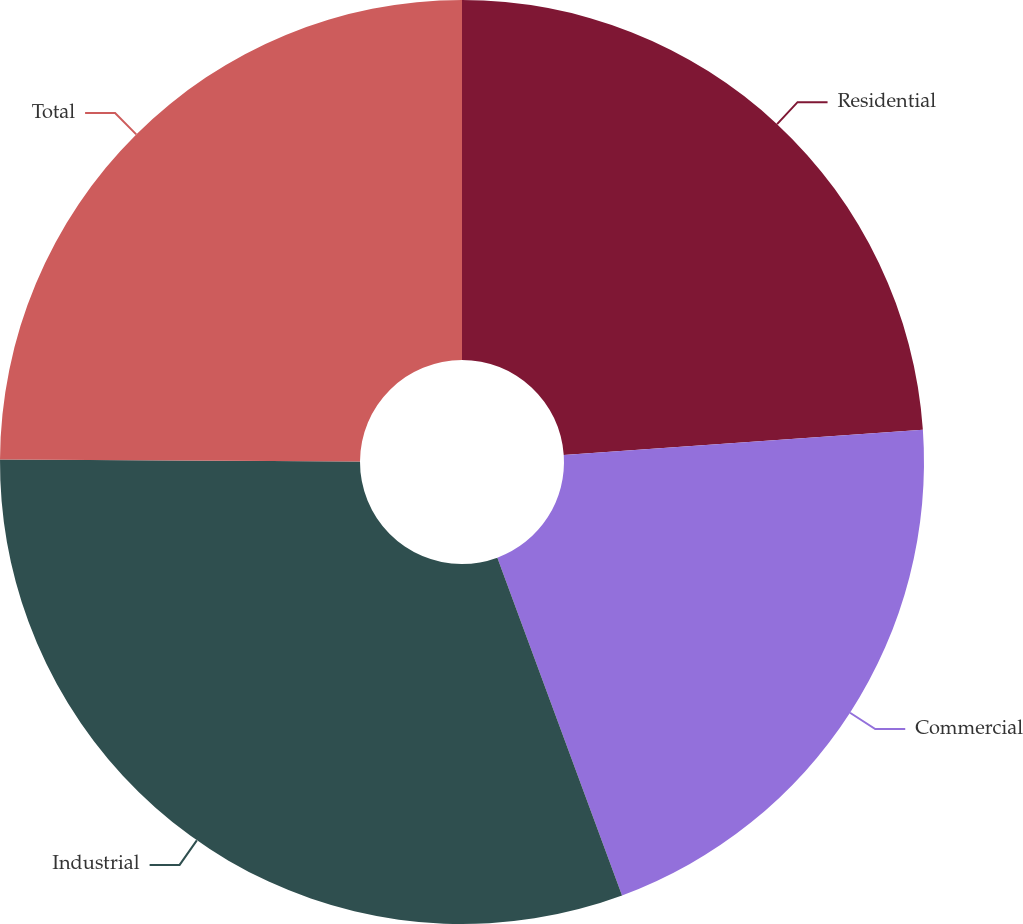Convert chart. <chart><loc_0><loc_0><loc_500><loc_500><pie_chart><fcel>Residential<fcel>Commercial<fcel>Industrial<fcel>Total<nl><fcel>23.89%<fcel>20.48%<fcel>30.72%<fcel>24.91%<nl></chart> 